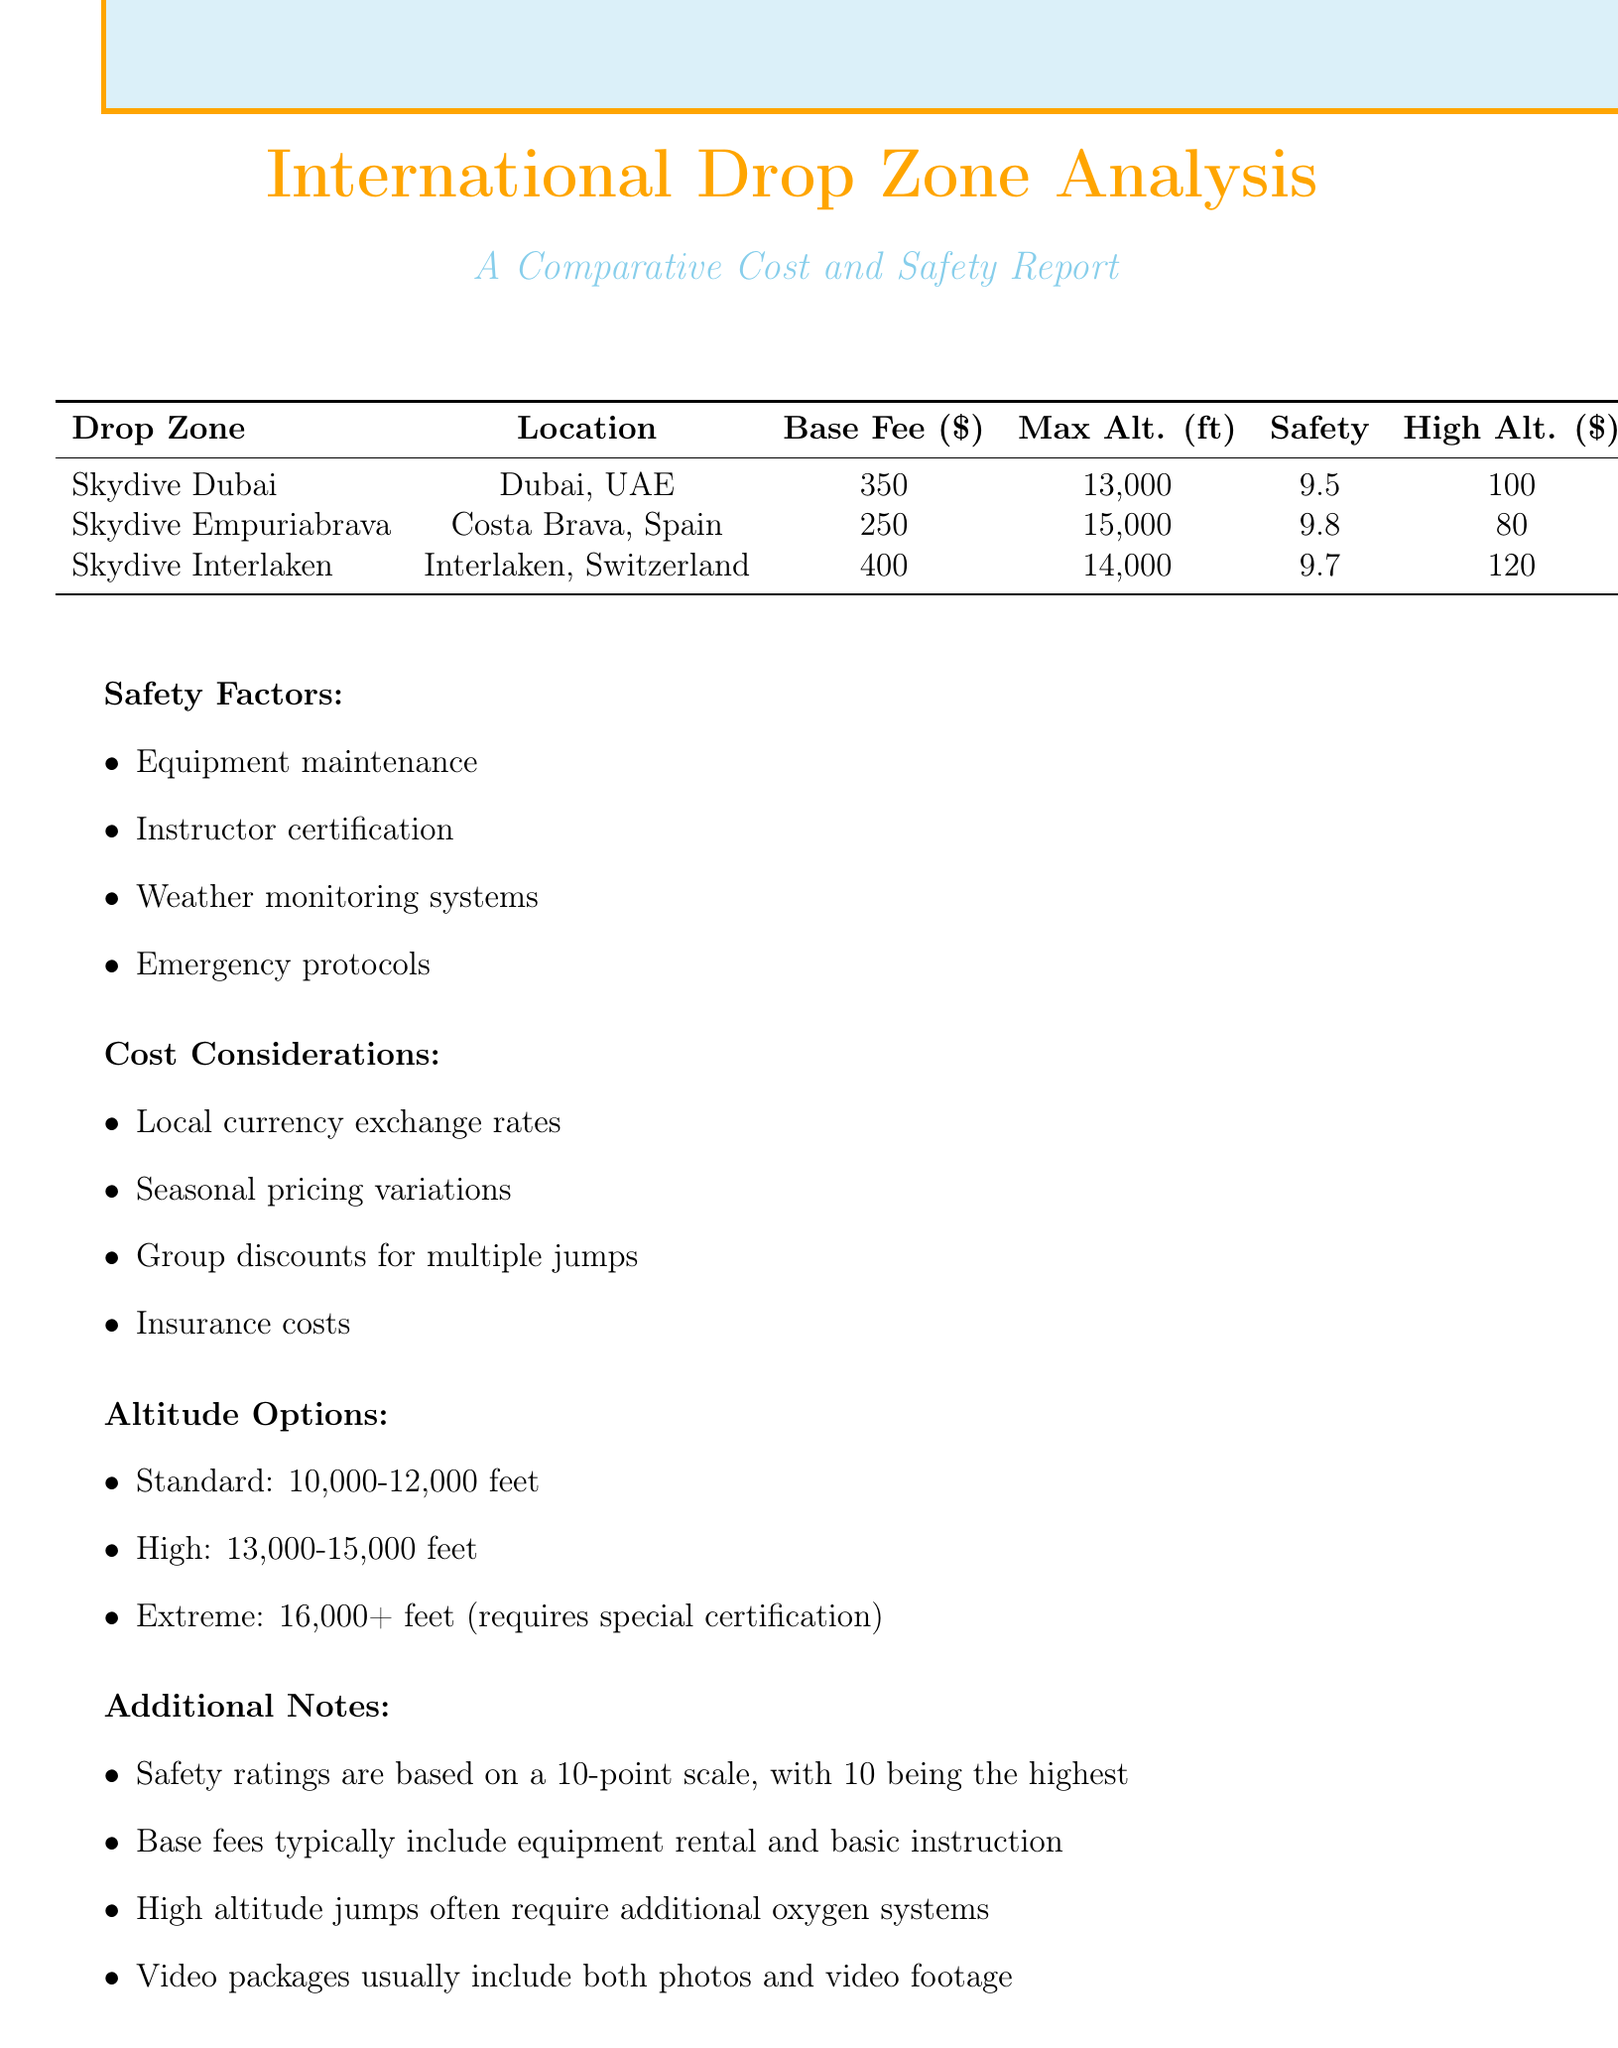what is the base fee for Skydive Dubai? The base fee for Skydive Dubai is provided in the table as $350.
Answer: $350 what is the maximum altitude for Skydive Empuriabrava? The maximum altitude for Skydive Empuriabrava is listed as 15,000 feet.
Answer: 15,000 feet which drop zone has the highest safety rating? The safety ratings for all drop zones are mentioned, with Skydive Empuriabrava having a rating of 9.8, the highest among them.
Answer: Skydive Empuriabrava what is the additional cost for a high altitude jump at Skydive Interlaken? The document states that the additional cost for a high altitude jump at Skydive Interlaken is $120.
Answer: $120 what are the safety factors included in the report? The report lists safety factors which include Equipment maintenance, Instructor certification, Weather monitoring systems, and Emergency protocols.
Answer: Equipment maintenance, Instructor certification, Weather monitoring systems, Emergency protocols how do the base fees compare between Skydive Dubai and Skydive Interlaken? The base fee for Skydive Dubai is $350, while for Skydive Interlaken, it is $400, showing that Interlaken has a higher fee.
Answer: Skydive Interlaken has a higher fee what is the altitude range listed for standard jumps? The document states that the altitude range for standard jumps is 10,000-12,000 feet.
Answer: 10,000-12,000 feet what does the base fee typically include? The additional notes clarify that base fees typically include equipment rental and basic instruction.
Answer: Equipment rental and basic instruction what is a common factor affecting costs listed in the report? Seasonal pricing variations are mentioned as one of the cost considerations affecting the expenses at drop zones.
Answer: Seasonal pricing variations 